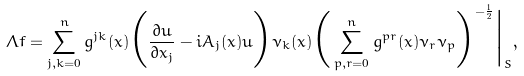Convert formula to latex. <formula><loc_0><loc_0><loc_500><loc_500>\Lambda f = \sum _ { j , k = 0 } ^ { n } g ^ { j k } ( x ) \Big ( \frac { \partial u } { \partial x _ { j } } - i A _ { j } ( x ) u \Big ) \nu _ { k } ( x ) \Big ( \sum _ { p , r = 0 } ^ { n } g ^ { p r } ( x ) \nu _ { r } \nu _ { p } \Big ) ^ { - \frac { 1 } { 2 } } \Big | _ { S } ,</formula> 